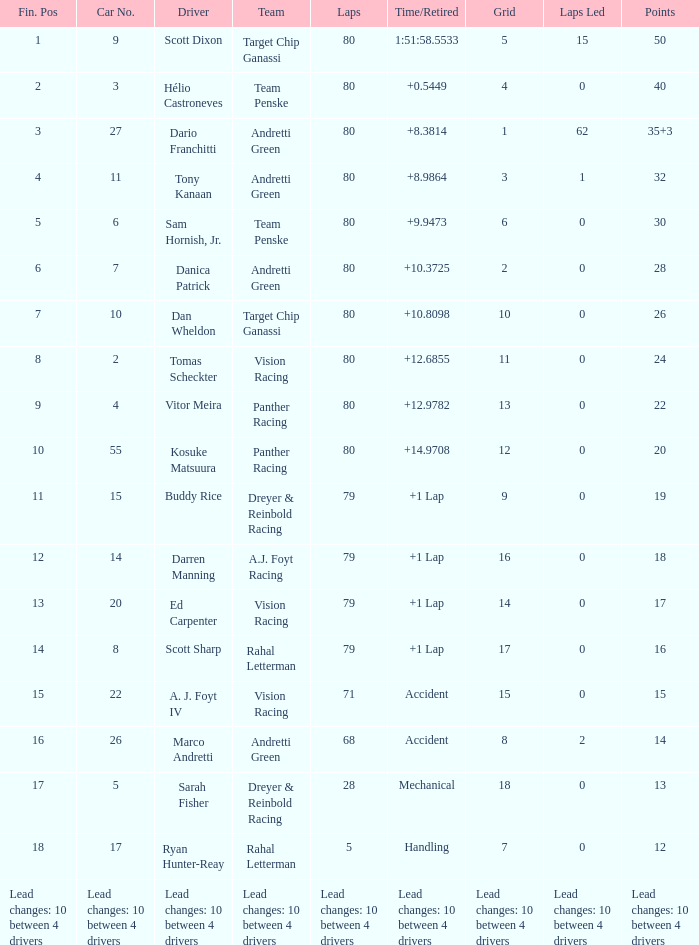How many points has kosuke matsuura, the driver, earned so far? 20.0. 